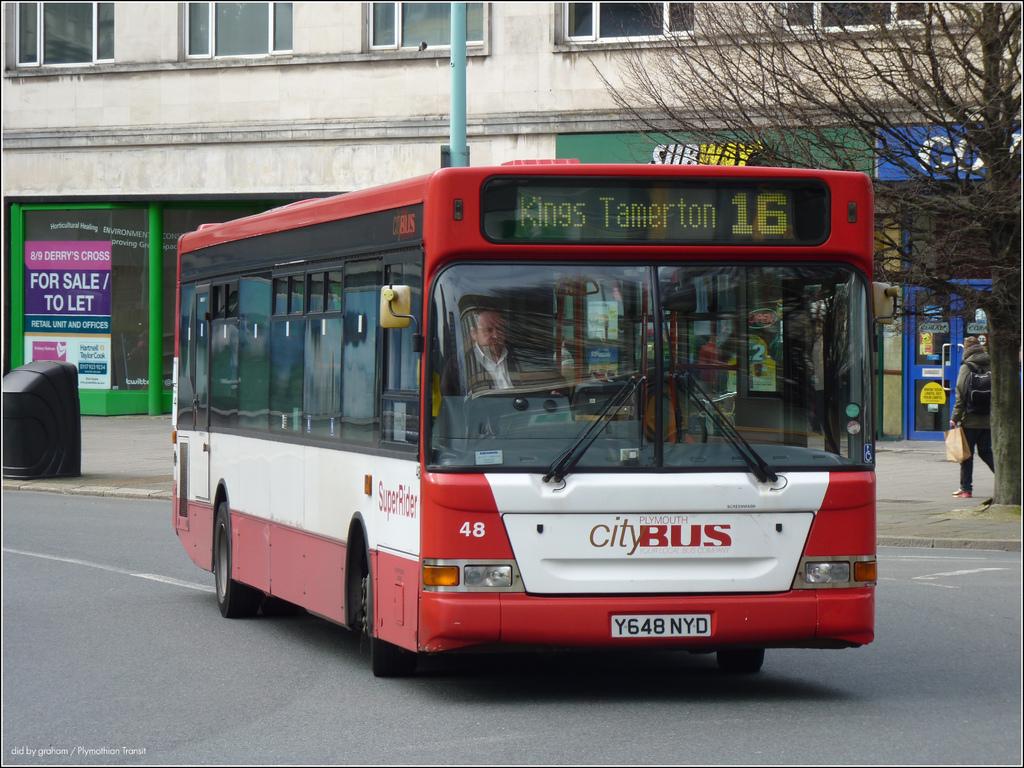Where is this city bus going?
Keep it short and to the point. Kings tamerton. 